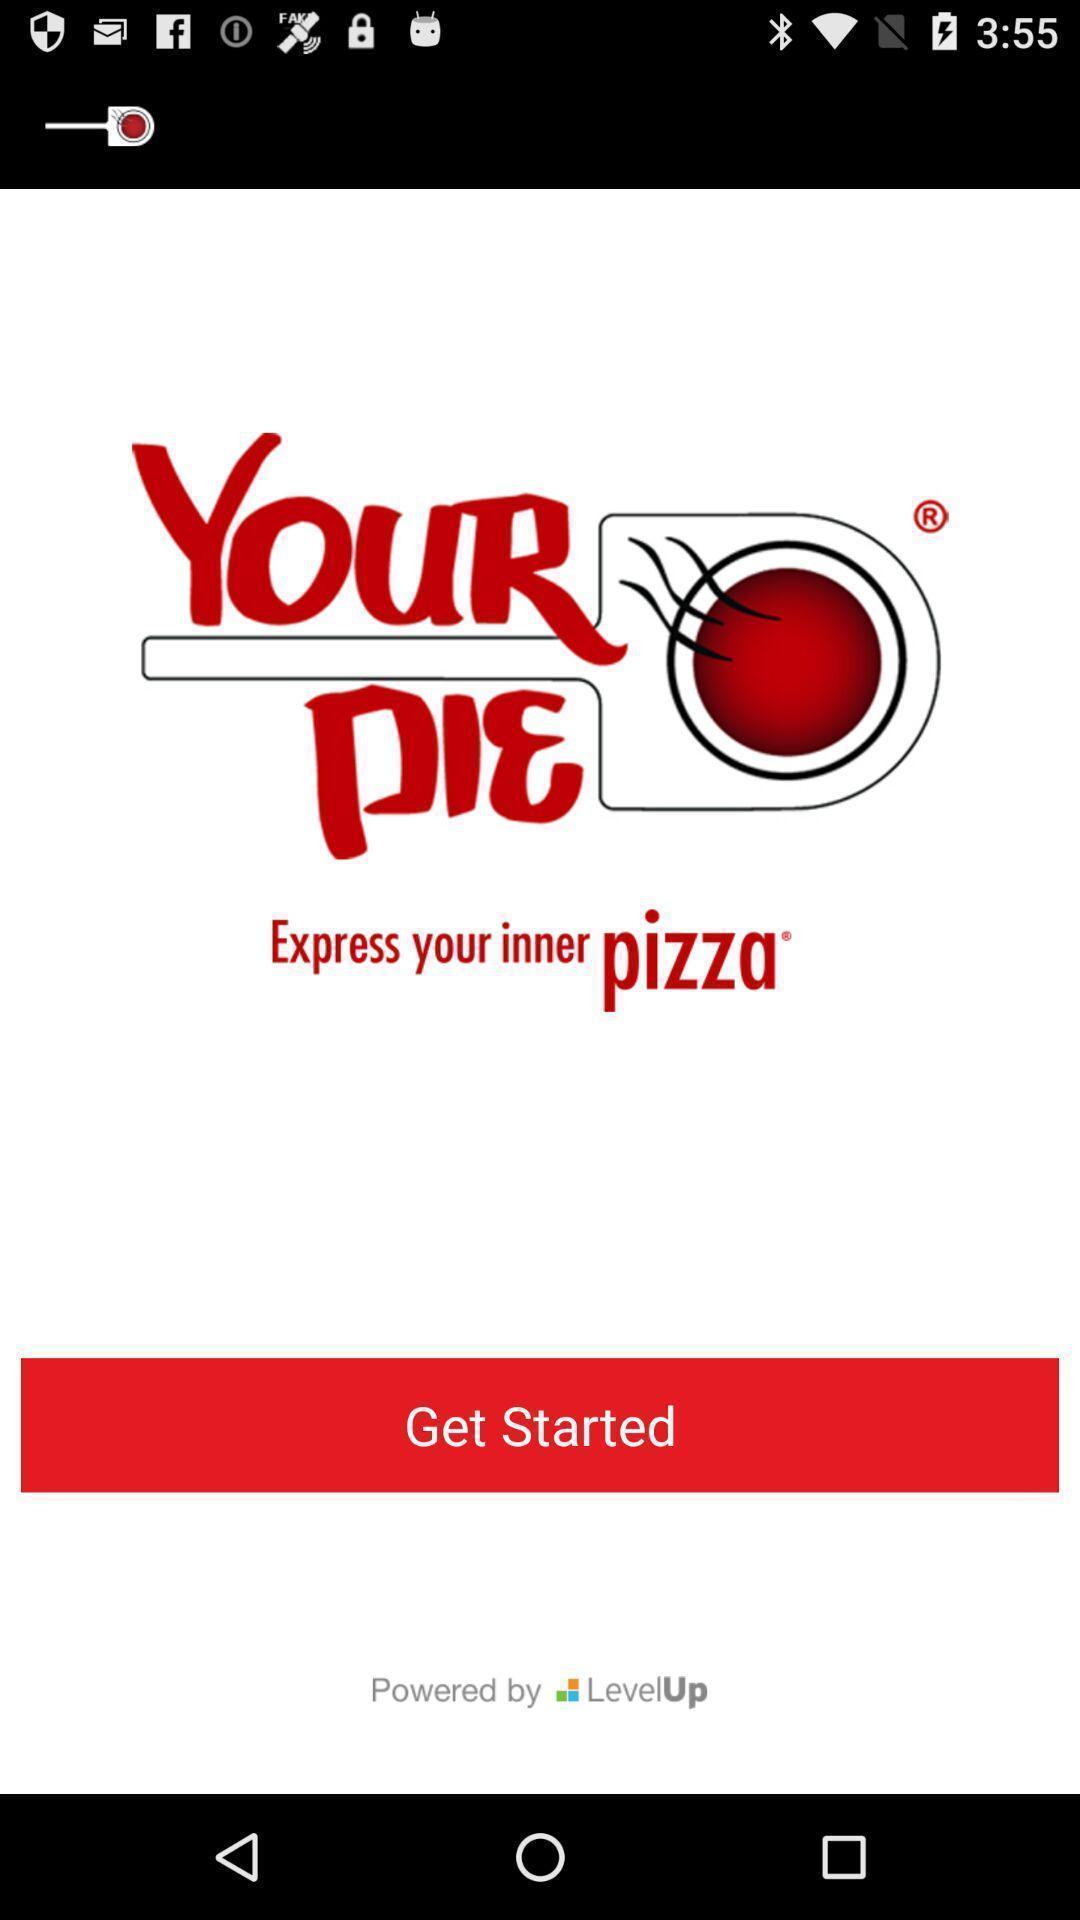Describe the key features of this screenshot. Welcome page of food app. 